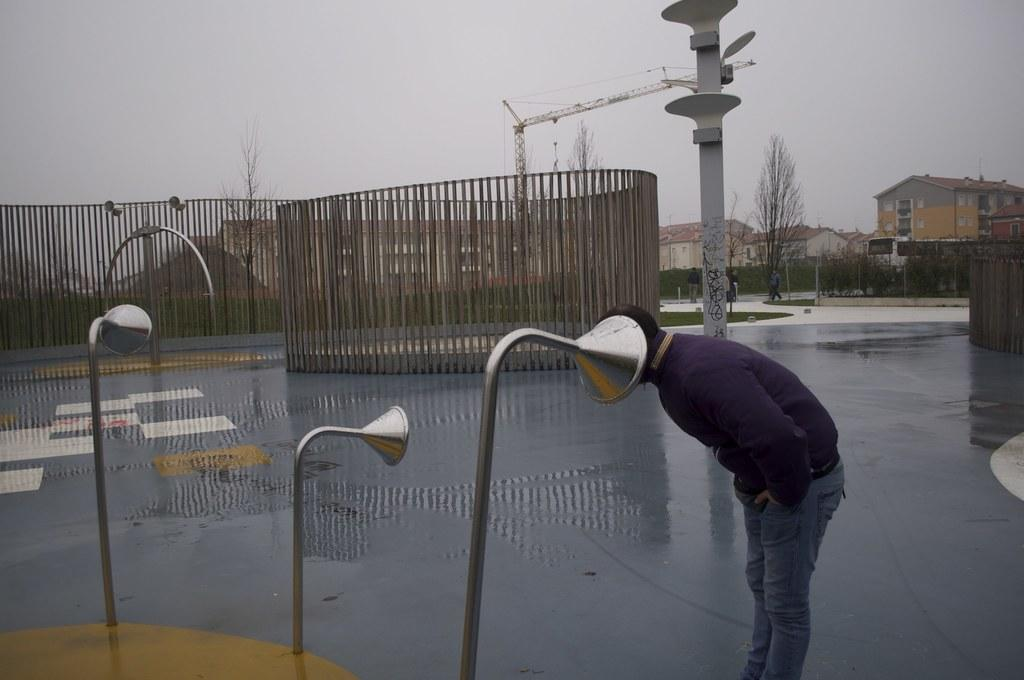What is the person in the image doing? The person is standing on the road in the image. What can be seen in the image related to cooking or food preparation? There are grills visible in the image. What type of machinery is present in the image? A construction crane is visible in the image. What tall structure is present in the image? There is a tower in the image. What type of man-made structures are present in the image? There are buildings in the image. What type of natural vegetation is present in the image? Trees are present in the image. What type of safety feature is present in the image? Barrier poles are visible in the image. What part of the natural environment is visible in the image? The sky is visible in the image. How many sugar cubes can be seen on the person's eye in the image? There are no sugar cubes or eyes visible in the image; it only shows a person standing on the road, grills, a construction crane, a tower, buildings, trees, barrier poles, and the sky. 